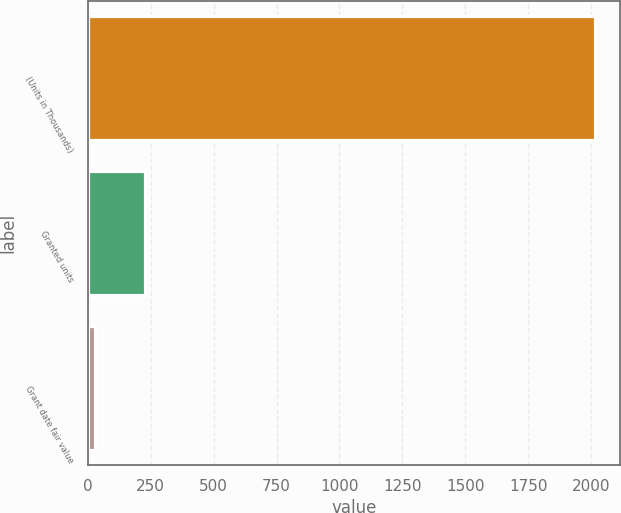Convert chart. <chart><loc_0><loc_0><loc_500><loc_500><bar_chart><fcel>(Units in Thousands)<fcel>Granted units<fcel>Grant date fair value<nl><fcel>2013<fcel>227.87<fcel>29.52<nl></chart> 